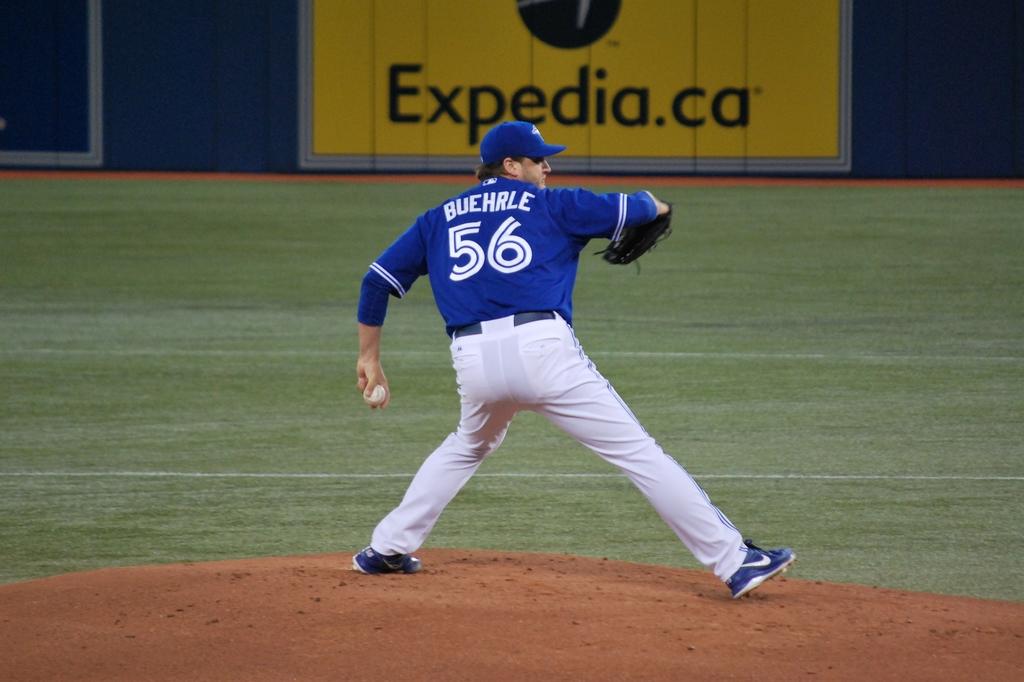What jersey number is on the pitcher?
Provide a short and direct response. 56. 